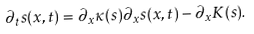Convert formula to latex. <formula><loc_0><loc_0><loc_500><loc_500>\partial _ { t } s ( x , t ) = \partial _ { x } \kappa ( s ) \partial _ { x } s ( x , t ) - \partial _ { x } K ( s ) .</formula> 